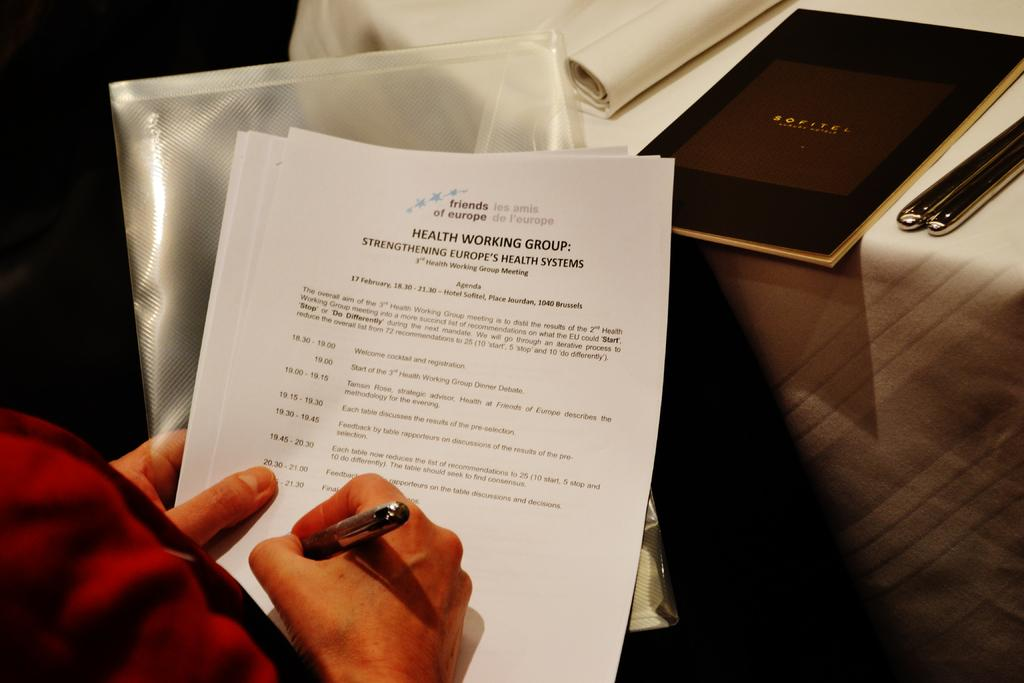<image>
Provide a brief description of the given image. A person writes on a document titled Health Working Group: Strengthening Europe's Health Systems. 